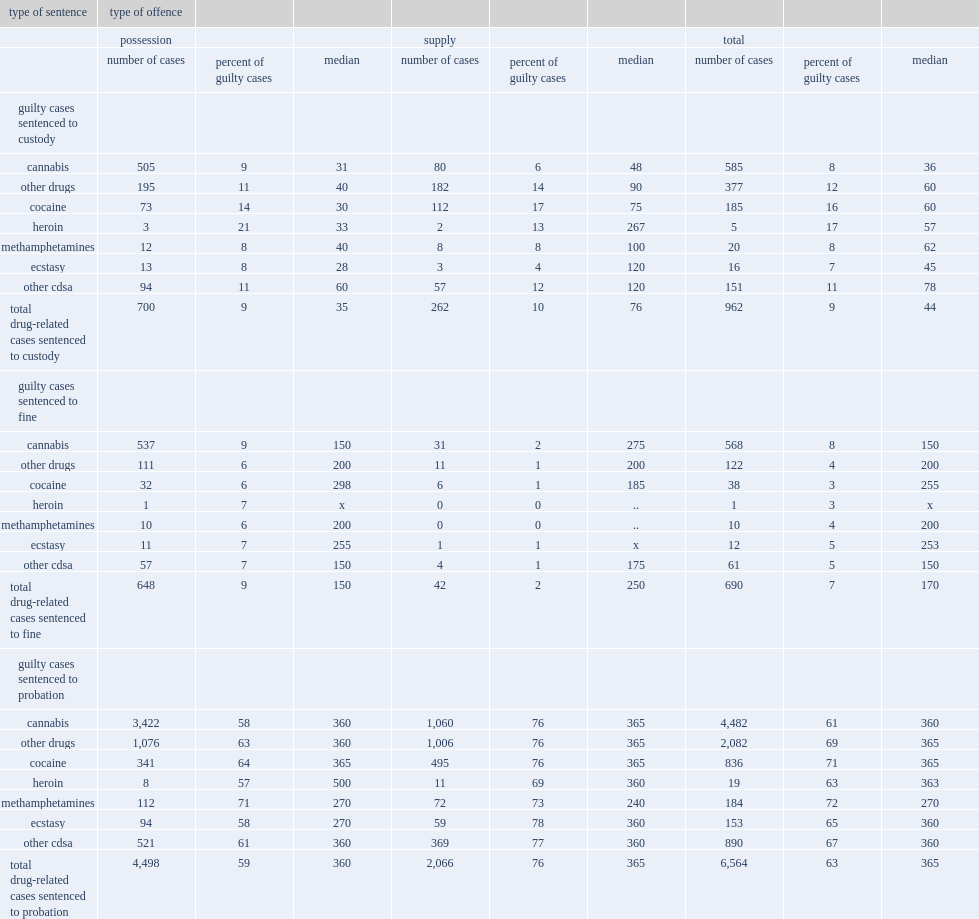What is the percentage of all completed drug-related cases with a decision of guilt in youth court involved a sentence of probation from 2008/2009 to 2011/2012? 63.0. What is the percentage of completed drug-related cases with a decision of guilt in youth court involved a sentence to custody from 2008/2009 to 2011/2012? 9.0. What is the percentage of completed drug-related cases with a decision of guilt in youth court involved a sentence to fine from 2008/2009 to 2011/2012? 7.0. 